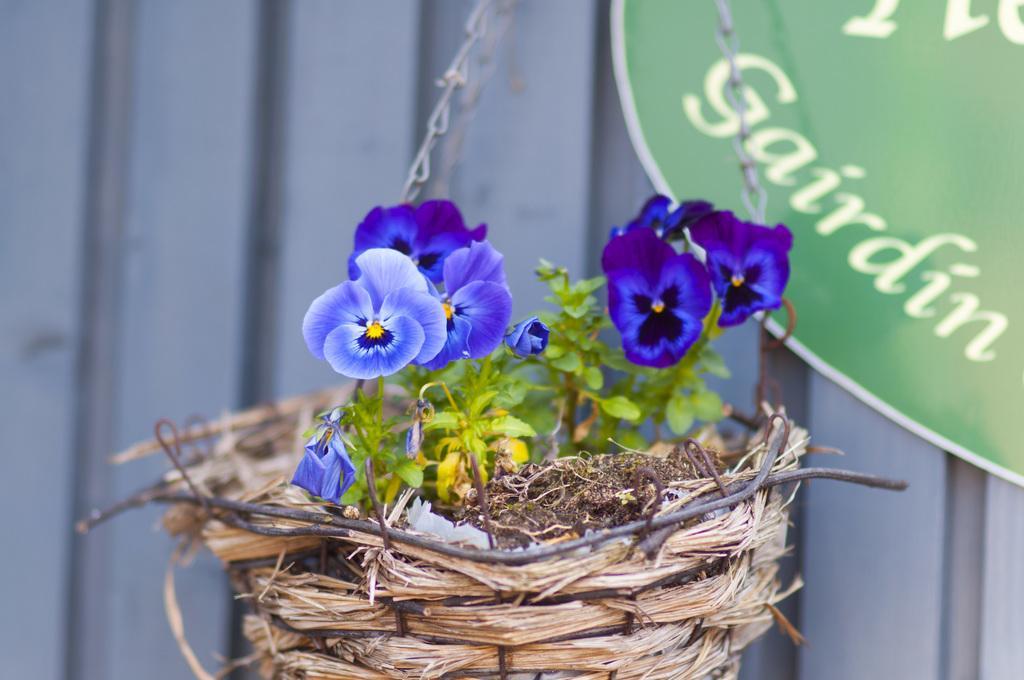Can you describe this image briefly? In this image, we can see a hanging basket contains a plant. There is a board in the top right of the image. In the background, image is blurred. 